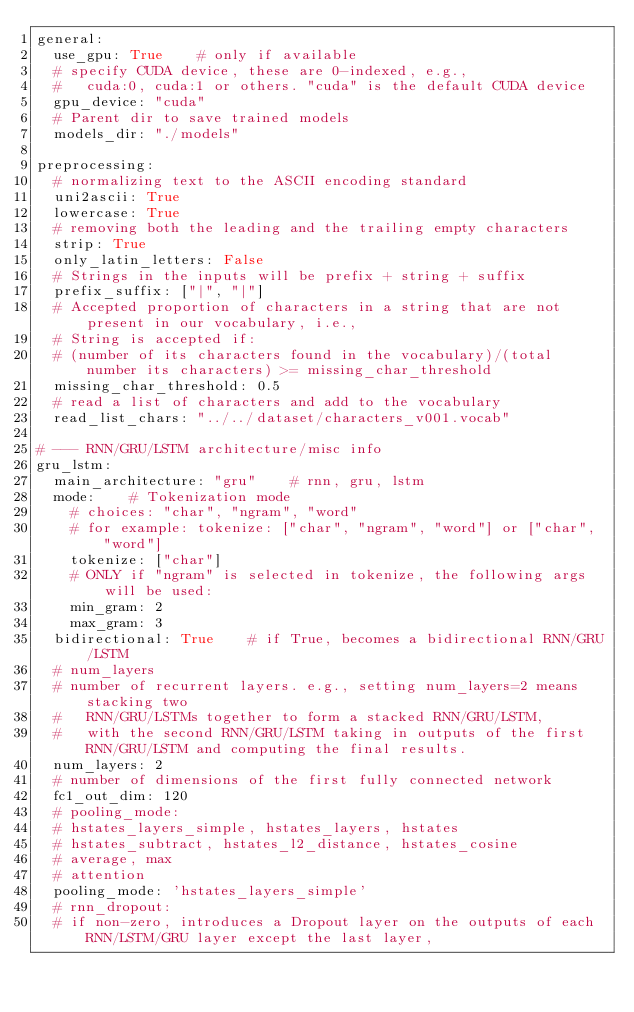<code> <loc_0><loc_0><loc_500><loc_500><_YAML_>general:
  use_gpu: True    # only if available
  # specify CUDA device, these are 0-indexed, e.g., 
  #   cuda:0, cuda:1 or others. "cuda" is the default CUDA device
  gpu_device: "cuda"
  # Parent dir to save trained models 
  models_dir: "./models"

preprocessing:
  # normalizing text to the ASCII encoding standard
  uni2ascii: True
  lowercase: True
  # removing both the leading and the trailing empty characters
  strip: True
  only_latin_letters: False
  # Strings in the inputs will be prefix + string + suffix
  prefix_suffix: ["|", "|"]
  # Accepted proportion of characters in a string that are not present in our vocabulary, i.e.,
  # String is accepted if:
  # (number of its characters found in the vocabulary)/(total number its characters) >= missing_char_threshold
  missing_char_threshold: 0.5
  # read a list of characters and add to the vocabulary
  read_list_chars: "../../dataset/characters_v001.vocab"

# --- RNN/GRU/LSTM architecture/misc info
gru_lstm:
  main_architecture: "gru"    # rnn, gru, lstm
  mode:    # Tokenization mode
    # choices: "char", "ngram", "word"
    # for example: tokenize: ["char", "ngram", "word"] or ["char", "word"] 
    tokenize: ["char"]
    # ONLY if "ngram" is selected in tokenize, the following args will be used:
    min_gram: 2
    max_gram: 3
  bidirectional: True    # if True, becomes a bidirectional RNN/GRU/LSTM
  # num_layers
  # number of recurrent layers. e.g., setting num_layers=2 means stacking two 
  #   RNN/GRU/LSTMs together to form a stacked RNN/GRU/LSTM,
  #   with the second RNN/GRU/LSTM taking in outputs of the first RNN/GRU/LSTM and computing the final results.
  num_layers: 2
  # number of dimensions of the first fully connected network
  fc1_out_dim: 120    
  # pooling_mode:
  # hstates_layers_simple, hstates_layers, hstates
  # hstates_subtract, hstates_l2_distance, hstates_cosine
  # average, max
  # attention
  pooling_mode: 'hstates_layers_simple'    
  # rnn_dropout:
  # if non-zero, introduces a Dropout layer on the outputs of each RNN/LSTM/GRU layer except the last layer,</code> 